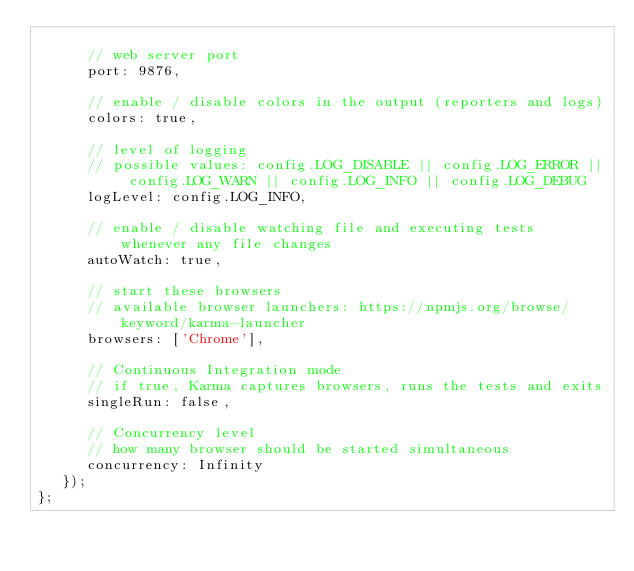<code> <loc_0><loc_0><loc_500><loc_500><_JavaScript_>
      // web server port
      port: 9876,

      // enable / disable colors in the output (reporters and logs)
      colors: true,

      // level of logging
      // possible values: config.LOG_DISABLE || config.LOG_ERROR || config.LOG_WARN || config.LOG_INFO || config.LOG_DEBUG
      logLevel: config.LOG_INFO,

      // enable / disable watching file and executing tests whenever any file changes
      autoWatch: true,

      // start these browsers
      // available browser launchers: https://npmjs.org/browse/keyword/karma-launcher
      browsers: ['Chrome'],

      // Continuous Integration mode
      // if true, Karma captures browsers, runs the tests and exits
      singleRun: false,

      // Concurrency level
      // how many browser should be started simultaneous
      concurrency: Infinity
   });
};</code> 